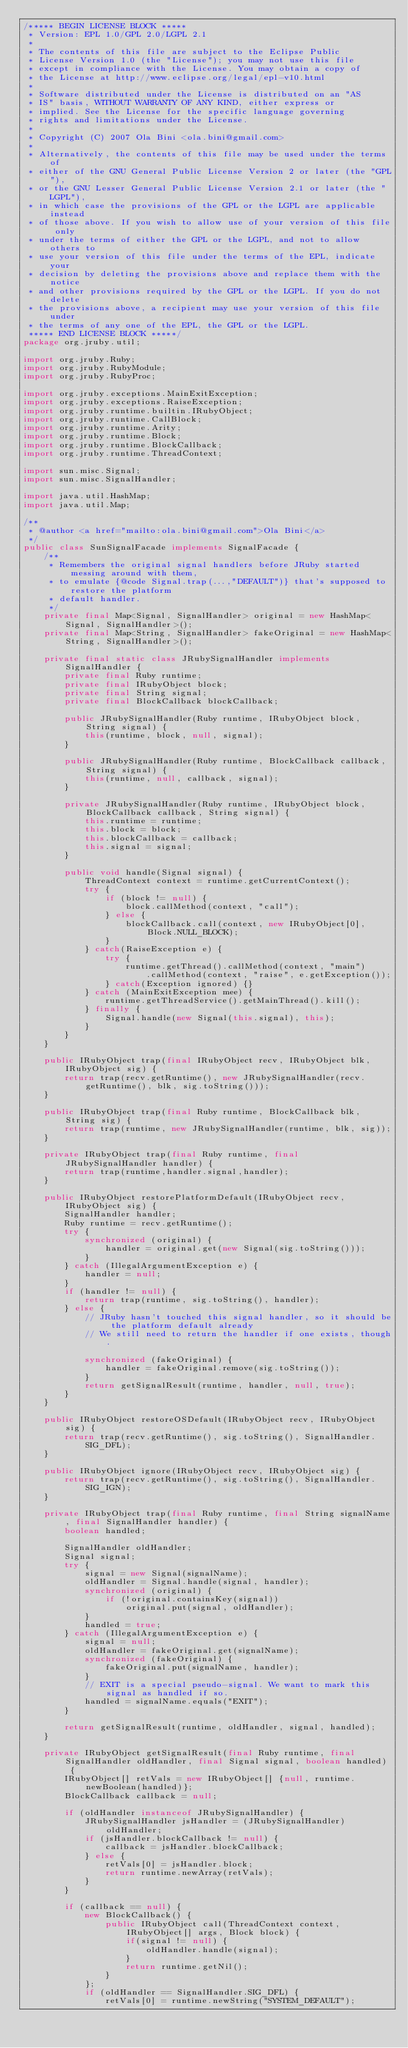Convert code to text. <code><loc_0><loc_0><loc_500><loc_500><_Java_>/***** BEGIN LICENSE BLOCK *****
 * Version: EPL 1.0/GPL 2.0/LGPL 2.1
 *
 * The contents of this file are subject to the Eclipse Public
 * License Version 1.0 (the "License"); you may not use this file
 * except in compliance with the License. You may obtain a copy of
 * the License at http://www.eclipse.org/legal/epl-v10.html
 *
 * Software distributed under the License is distributed on an "AS
 * IS" basis, WITHOUT WARRANTY OF ANY KIND, either express or
 * implied. See the License for the specific language governing
 * rights and limitations under the License.
 *
 * Copyright (C) 2007 Ola Bini <ola.bini@gmail.com>
 * 
 * Alternatively, the contents of this file may be used under the terms of
 * either of the GNU General Public License Version 2 or later (the "GPL"),
 * or the GNU Lesser General Public License Version 2.1 or later (the "LGPL"),
 * in which case the provisions of the GPL or the LGPL are applicable instead
 * of those above. If you wish to allow use of your version of this file only
 * under the terms of either the GPL or the LGPL, and not to allow others to
 * use your version of this file under the terms of the EPL, indicate your
 * decision by deleting the provisions above and replace them with the notice
 * and other provisions required by the GPL or the LGPL. If you do not delete
 * the provisions above, a recipient may use your version of this file under
 * the terms of any one of the EPL, the GPL or the LGPL.
 ***** END LICENSE BLOCK *****/
package org.jruby.util;

import org.jruby.Ruby;
import org.jruby.RubyModule;
import org.jruby.RubyProc;

import org.jruby.exceptions.MainExitException;
import org.jruby.exceptions.RaiseException;
import org.jruby.runtime.builtin.IRubyObject;
import org.jruby.runtime.CallBlock;
import org.jruby.runtime.Arity;
import org.jruby.runtime.Block;
import org.jruby.runtime.BlockCallback;
import org.jruby.runtime.ThreadContext;

import sun.misc.Signal;
import sun.misc.SignalHandler;

import java.util.HashMap;
import java.util.Map;

/**
 * @author <a href="mailto:ola.bini@gmail.com">Ola Bini</a>
 */
public class SunSignalFacade implements SignalFacade {
    /**
     * Remembers the original signal handlers before JRuby started messing around with them,
     * to emulate {@code Signal.trap(...,"DEFAULT")} that's supposed to restore the platform
     * default handler.
     */
    private final Map<Signal, SignalHandler> original = new HashMap<Signal, SignalHandler>();
    private final Map<String, SignalHandler> fakeOriginal = new HashMap<String, SignalHandler>();
    
    private final static class JRubySignalHandler implements SignalHandler {
        private final Ruby runtime;
        private final IRubyObject block;
        private final String signal;
        private final BlockCallback blockCallback;

        public JRubySignalHandler(Ruby runtime, IRubyObject block, String signal) {
            this(runtime, block, null, signal);
        }

        public JRubySignalHandler(Ruby runtime, BlockCallback callback, String signal) {
            this(runtime, null, callback, signal);
        }

        private JRubySignalHandler(Ruby runtime, IRubyObject block, BlockCallback callback, String signal) {
            this.runtime = runtime;
            this.block = block;
            this.blockCallback = callback;
            this.signal = signal;
        }

        public void handle(Signal signal) {
            ThreadContext context = runtime.getCurrentContext();
            try {
                if (block != null) {
                    block.callMethod(context, "call");
                } else {
                    blockCallback.call(context, new IRubyObject[0], Block.NULL_BLOCK);
                }
            } catch(RaiseException e) {
                try {
                    runtime.getThread().callMethod(context, "main")
                        .callMethod(context, "raise", e.getException());
                } catch(Exception ignored) {}
            } catch (MainExitException mee) {
                runtime.getThreadService().getMainThread().kill();
            } finally {
                Signal.handle(new Signal(this.signal), this);
            }
        }
    }

    public IRubyObject trap(final IRubyObject recv, IRubyObject blk, IRubyObject sig) {
        return trap(recv.getRuntime(), new JRubySignalHandler(recv.getRuntime(), blk, sig.toString()));
    }
        
    public IRubyObject trap(final Ruby runtime, BlockCallback blk, String sig) {
        return trap(runtime, new JRubySignalHandler(runtime, blk, sig));
    }

    private IRubyObject trap(final Ruby runtime, final JRubySignalHandler handler) {
        return trap(runtime,handler.signal,handler);
    }

    public IRubyObject restorePlatformDefault(IRubyObject recv, IRubyObject sig) {
        SignalHandler handler;
        Ruby runtime = recv.getRuntime();
        try {
            synchronized (original) {
                handler = original.get(new Signal(sig.toString()));
            }
        } catch (IllegalArgumentException e) {
            handler = null;
        }
        if (handler != null) {
            return trap(runtime, sig.toString(), handler);
        } else {
            // JRuby hasn't touched this signal handler, so it should be the platform default already
            // We still need to return the handler if one exists, though.

            synchronized (fakeOriginal) {
                handler = fakeOriginal.remove(sig.toString());
            }
            return getSignalResult(runtime, handler, null, true);
        }
    }

    public IRubyObject restoreOSDefault(IRubyObject recv, IRubyObject sig) {
        return trap(recv.getRuntime(), sig.toString(), SignalHandler.SIG_DFL);
    }

    public IRubyObject ignore(IRubyObject recv, IRubyObject sig) {
        return trap(recv.getRuntime(), sig.toString(), SignalHandler.SIG_IGN);
    }

    private IRubyObject trap(final Ruby runtime, final String signalName, final SignalHandler handler) {
        boolean handled;

        SignalHandler oldHandler;
        Signal signal;
        try {
            signal = new Signal(signalName);
            oldHandler = Signal.handle(signal, handler);
            synchronized (original) {
                if (!original.containsKey(signal))
                    original.put(signal, oldHandler);
            }
            handled = true;
        } catch (IllegalArgumentException e) {
            signal = null;
            oldHandler = fakeOriginal.get(signalName);
            synchronized (fakeOriginal) {
                fakeOriginal.put(signalName, handler);
            }
            // EXIT is a special pseudo-signal. We want to mark this signal as handled if so.
            handled = signalName.equals("EXIT");
        }

        return getSignalResult(runtime, oldHandler, signal, handled);
    }

    private IRubyObject getSignalResult(final Ruby runtime, final SignalHandler oldHandler, final Signal signal, boolean handled) {
        IRubyObject[] retVals = new IRubyObject[] {null, runtime.newBoolean(handled)};
        BlockCallback callback = null;

        if (oldHandler instanceof JRubySignalHandler) {
            JRubySignalHandler jsHandler = (JRubySignalHandler) oldHandler;
            if (jsHandler.blockCallback != null) {
                callback = jsHandler.blockCallback;
            } else {
                retVals[0] = jsHandler.block;
                return runtime.newArray(retVals);
            }
        }

        if (callback == null) {
            new BlockCallback() {
                public IRubyObject call(ThreadContext context, IRubyObject[] args, Block block) {
                    if(signal != null) {
                        oldHandler.handle(signal);
                    }
                    return runtime.getNil();
                }
            };
            if (oldHandler == SignalHandler.SIG_DFL) {
                retVals[0] = runtime.newString("SYSTEM_DEFAULT");</code> 